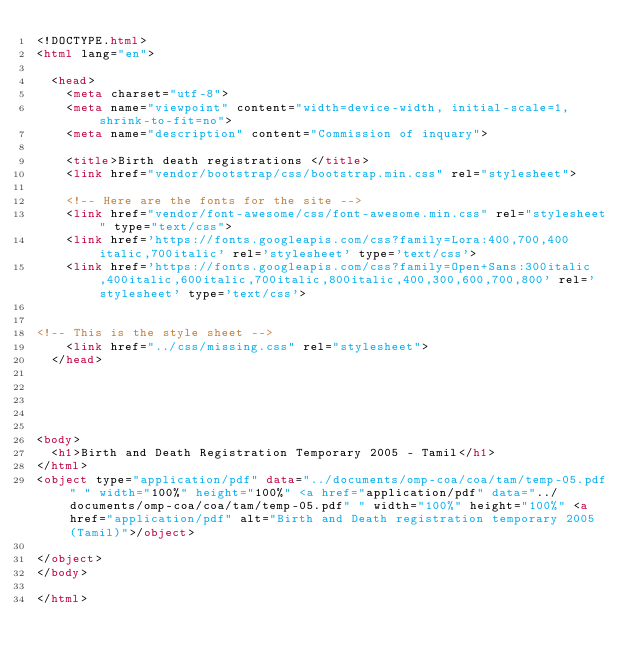Convert code to text. <code><loc_0><loc_0><loc_500><loc_500><_HTML_><!DOCTYPE.html>
<html lang="en">

  <head>
  	<meta charset="utf-8">
  	<meta name="viewpoint" content="width=device-width, initial-scale=1, shrink-to-fit=no">
  	<meta name="description" content="Commission of inquary">

  	<title>Birth death registrations </title>
  	<link href="vendor/bootstrap/css/bootstrap.min.css" rel="stylesheet">

    <!-- Here are the fonts for the site -->
    <link href="vendor/font-awesome/css/font-awesome.min.css" rel="stylesheet" type="text/css">
    <link href='https://fonts.googleapis.com/css?family=Lora:400,700,400italic,700italic' rel='stylesheet' type='text/css'>
    <link href='https://fonts.googleapis.com/css?family=Open+Sans:300italic,400italic,600italic,700italic,800italic,400,300,600,700,800' rel='stylesheet' type='text/css'>


<!-- This is the style sheet -->
    <link href="../css/missing.css" rel="stylesheet">
  </head>





<body>
	<h1>Birth and Death Registration Temporary 2005 - Tamil</h1>
</html>
<object type="application/pdf" data="../documents/omp-coa/coa/tam/temp-05.pdf" " width="100%" height="100%" <a href="application/pdf" data="../documents/omp-coa/coa/tam/temp-05.pdf" " width="100%" height="100%" <a href="application/pdf" alt="Birth and Death registration temporary 2005 (Tamil)">/object>

</object>
</body>

</html></code> 